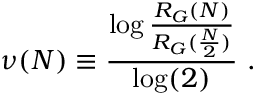<formula> <loc_0><loc_0><loc_500><loc_500>\nu ( N ) \equiv \frac { \log \frac { R _ { G } ( N ) } { R _ { G } ( \frac { N } { 2 } ) } } { \log ( 2 ) } \ .</formula> 